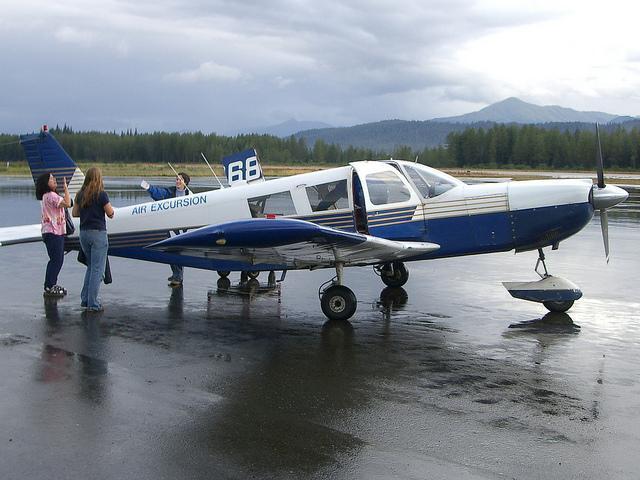How many people are there?
Give a very brief answer. 2. How many mice are there?
Give a very brief answer. 0. 